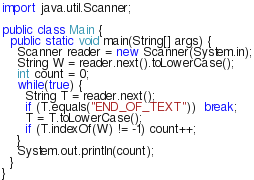<code> <loc_0><loc_0><loc_500><loc_500><_Java_>import java.util.Scanner;

public class Main {
  public static void main(String[] args) {
    Scanner reader = new Scanner(System.in);
    String W = reader.next().toLowerCase();
    int count = 0;
    while(true) {
      String T = reader.next();
      if (T.equals("END_OF_TEXT"))  break;
      T = T.toLowerCase();
      if (T.indexOf(W) != -1) count++;
    }
    System.out.println(count);
  }
}</code> 